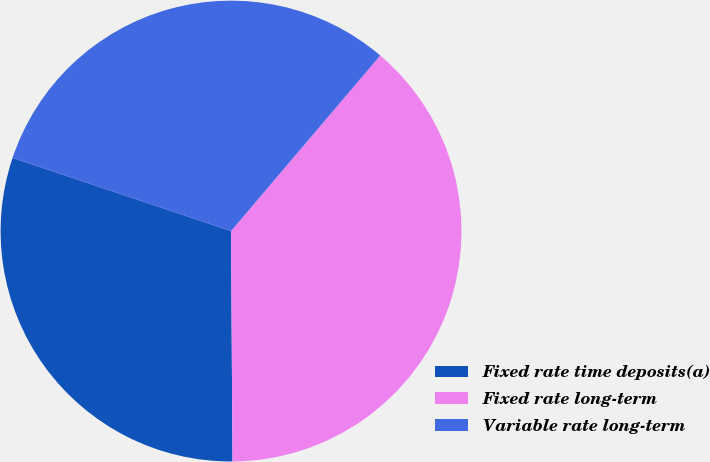<chart> <loc_0><loc_0><loc_500><loc_500><pie_chart><fcel>Fixed rate time deposits(a)<fcel>Fixed rate long-term<fcel>Variable rate long-term<nl><fcel>30.25%<fcel>38.69%<fcel>31.06%<nl></chart> 